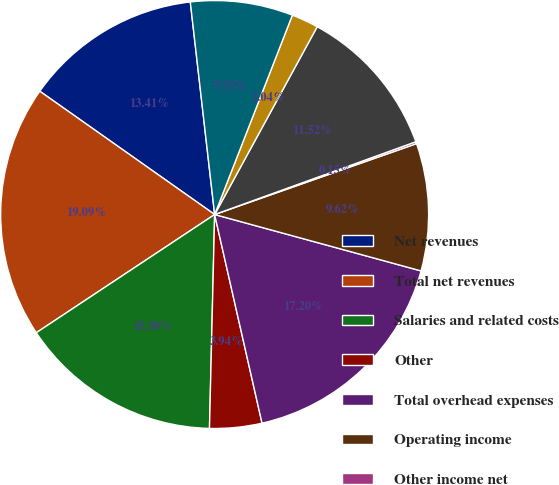Convert chart. <chart><loc_0><loc_0><loc_500><loc_500><pie_chart><fcel>Net revenues<fcel>Total net revenues<fcel>Salaries and related costs<fcel>Other<fcel>Total overhead expenses<fcel>Operating income<fcel>Other income net<fcel>Earnings before income taxes<fcel>Income tax expense<fcel>Net earnings<nl><fcel>13.41%<fcel>19.09%<fcel>15.3%<fcel>3.94%<fcel>17.2%<fcel>9.62%<fcel>0.15%<fcel>11.52%<fcel>2.04%<fcel>7.73%<nl></chart> 